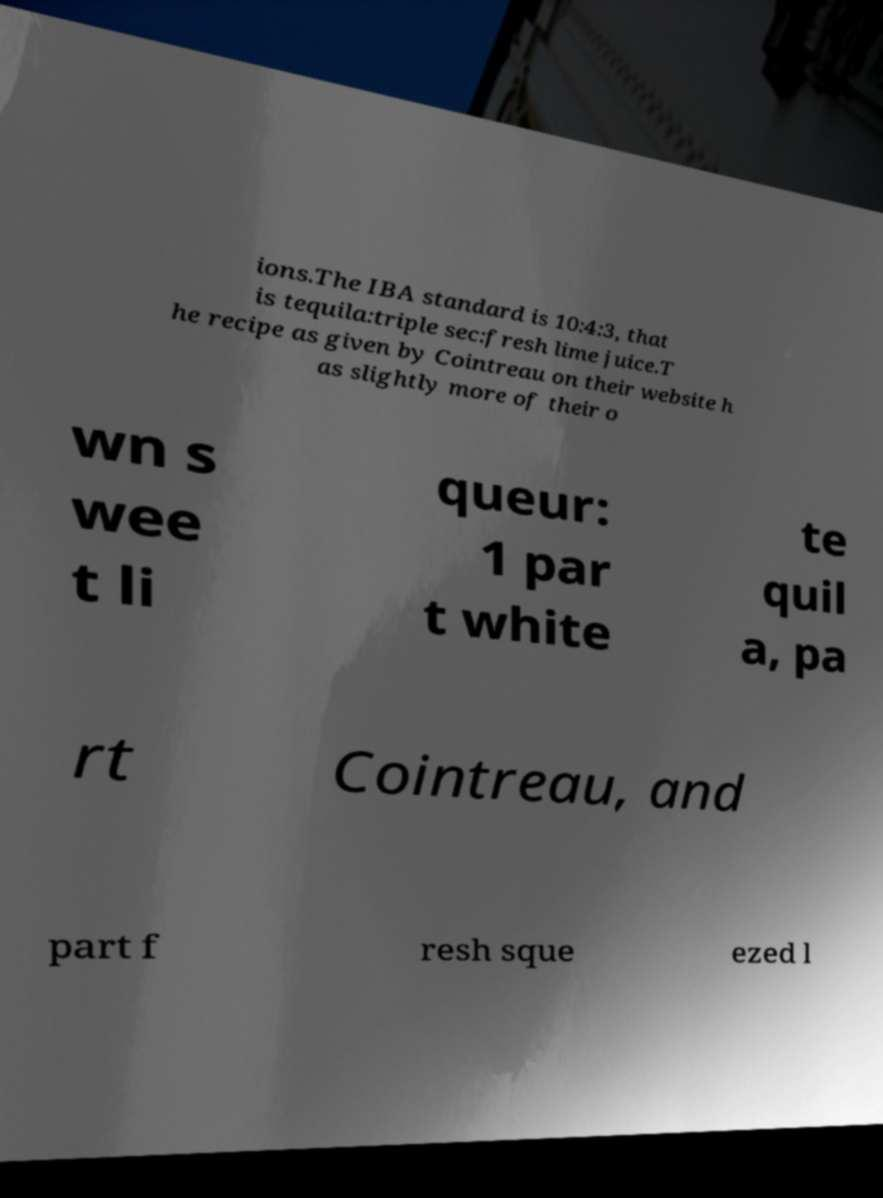Please read and relay the text visible in this image. What does it say? ions.The IBA standard is 10:4:3, that is tequila:triple sec:fresh lime juice.T he recipe as given by Cointreau on their website h as slightly more of their o wn s wee t li queur: 1 par t white te quil a, pa rt Cointreau, and part f resh sque ezed l 